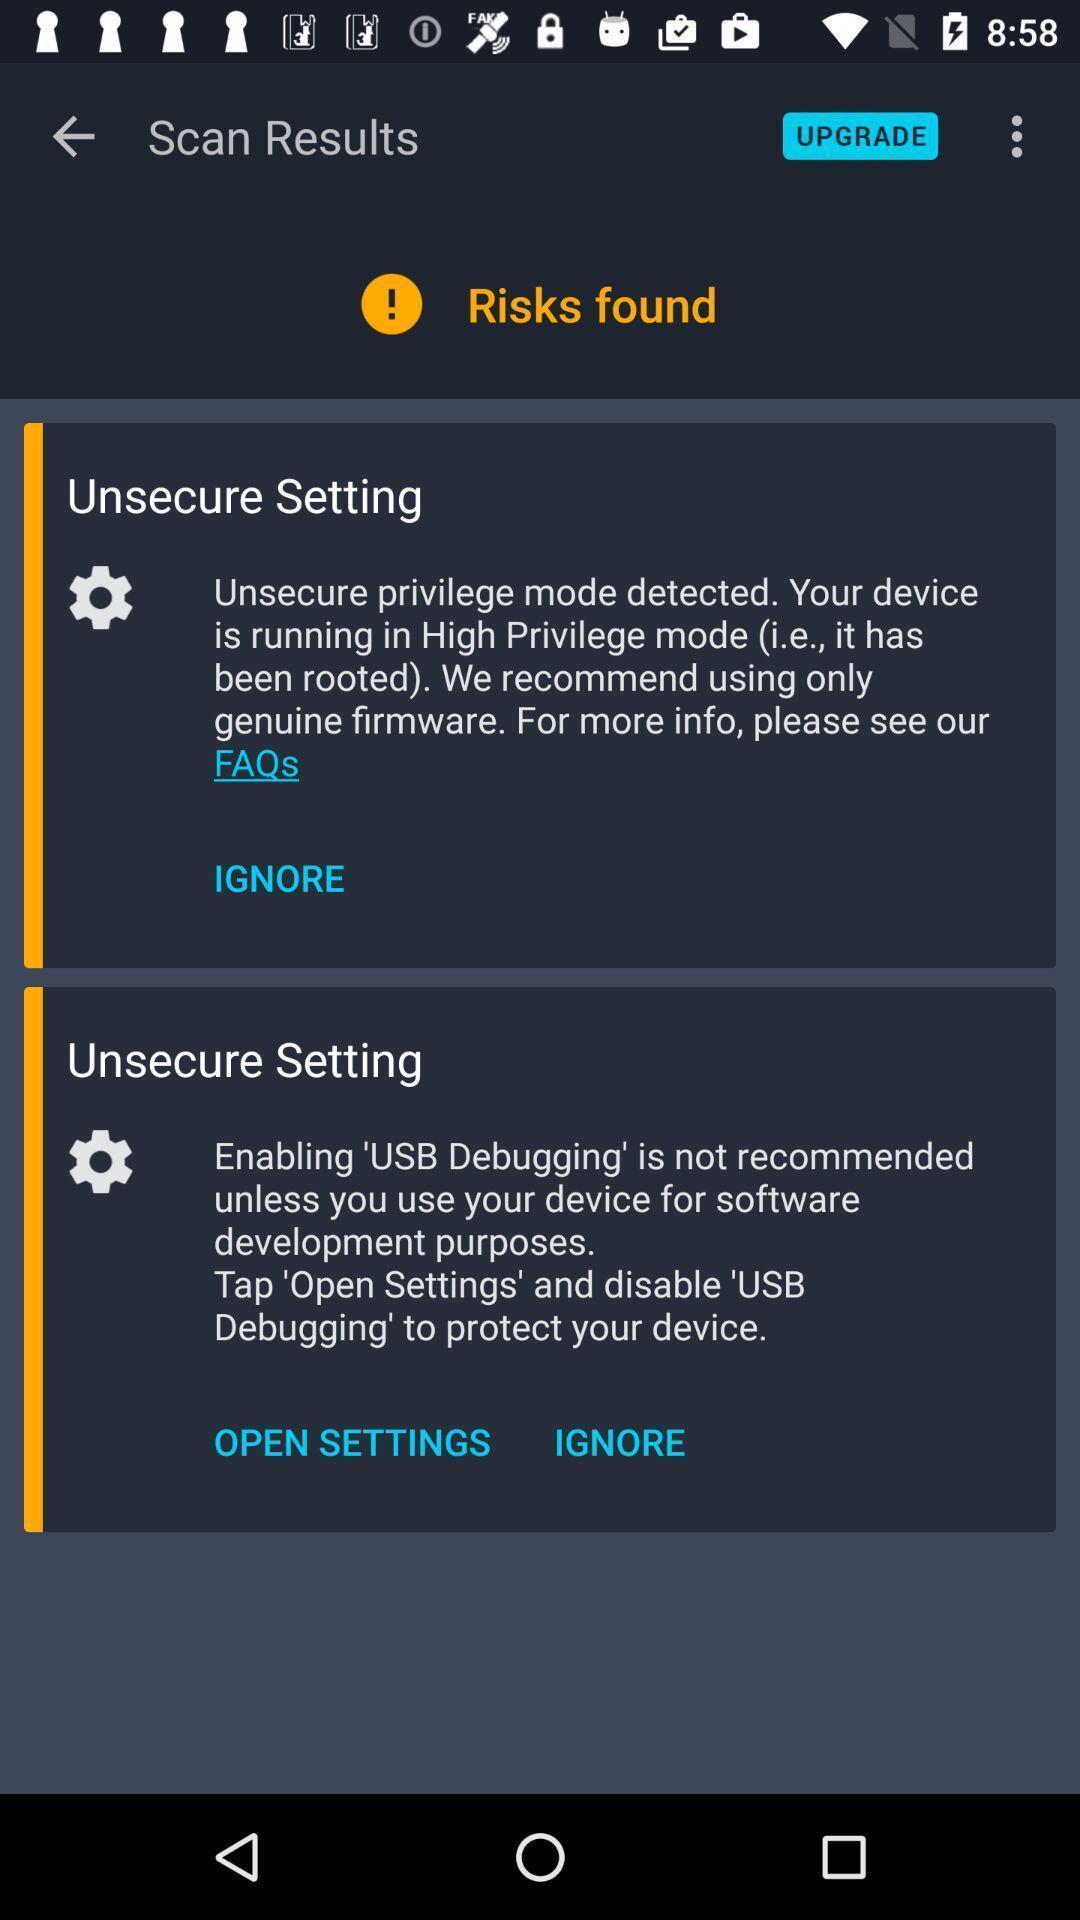Explain the elements present in this screenshot. Screen showing risk found. 